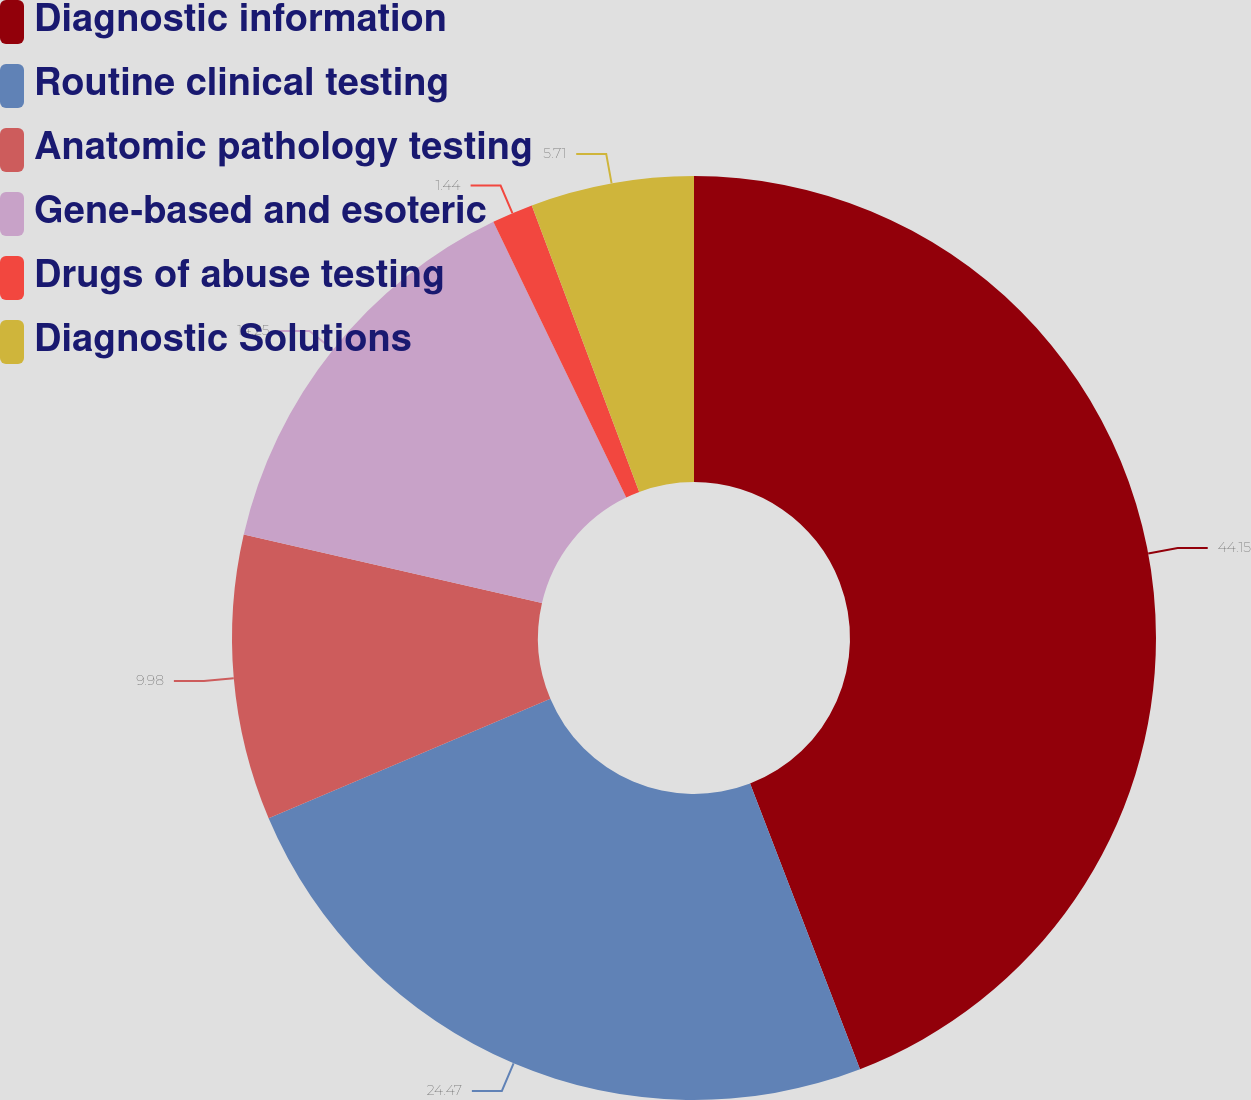Convert chart to OTSL. <chart><loc_0><loc_0><loc_500><loc_500><pie_chart><fcel>Diagnostic information<fcel>Routine clinical testing<fcel>Anatomic pathology testing<fcel>Gene-based and esoteric<fcel>Drugs of abuse testing<fcel>Diagnostic Solutions<nl><fcel>44.15%<fcel>24.47%<fcel>9.98%<fcel>14.25%<fcel>1.44%<fcel>5.71%<nl></chart> 